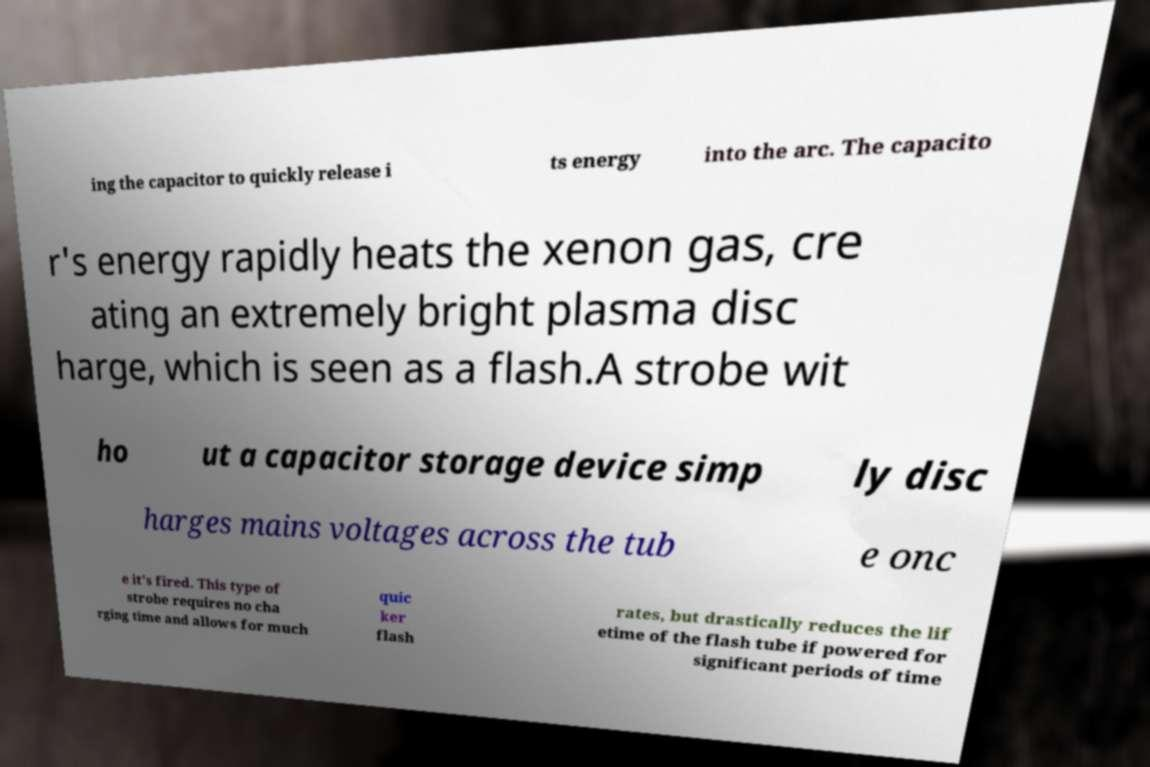For documentation purposes, I need the text within this image transcribed. Could you provide that? ing the capacitor to quickly release i ts energy into the arc. The capacito r's energy rapidly heats the xenon gas, cre ating an extremely bright plasma disc harge, which is seen as a flash.A strobe wit ho ut a capacitor storage device simp ly disc harges mains voltages across the tub e onc e it's fired. This type of strobe requires no cha rging time and allows for much quic ker flash rates, but drastically reduces the lif etime of the flash tube if powered for significant periods of time 